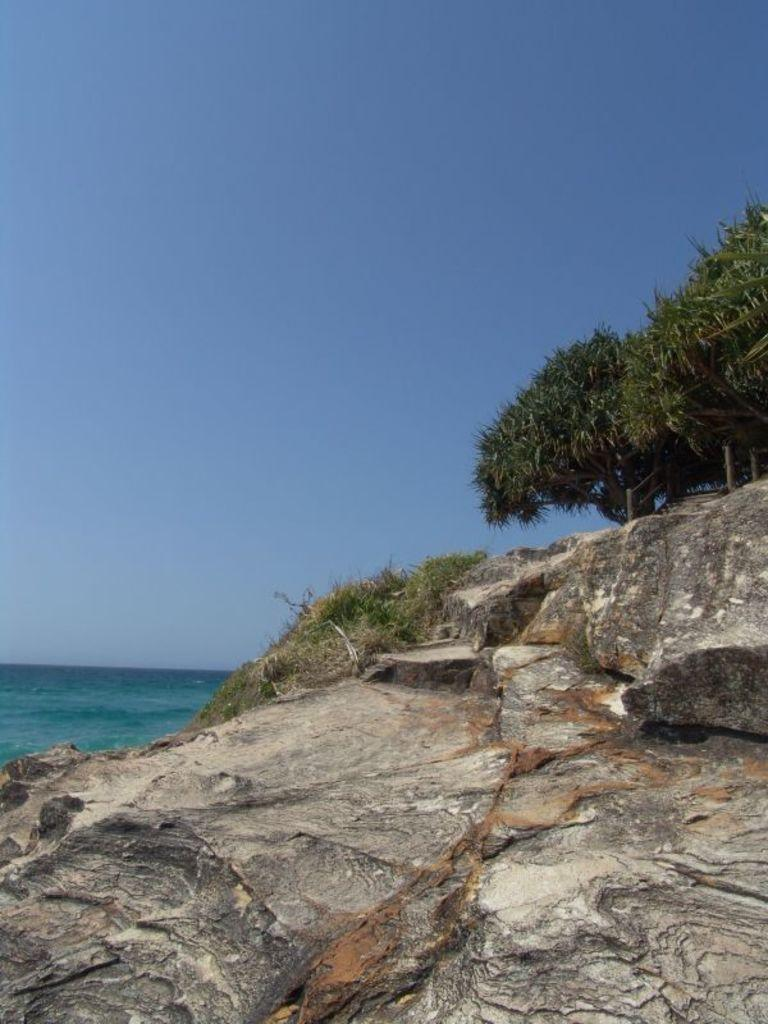What is the main subject of the image? There is a rock in the image. What type of vegetation can be seen in the image? There is grass in the image. What natural element is visible in the image? There is water visible in the image. What can be seen in the background of the image? There are trees and a blue sky in the background of the image. Can you see the collar of the dog in the image? There is no dog or collar present in the image. How many levels can be seen in the image? The image does not depict any structures with levels; it features a rock, grass, water, trees, and a blue sky. 